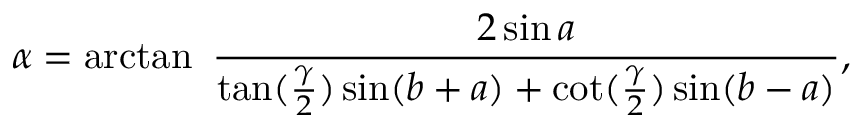<formula> <loc_0><loc_0><loc_500><loc_500>\alpha = \arctan \ { \frac { 2 \sin a } { \tan ( { \frac { \gamma } { 2 } } ) \sin ( b + a ) + \cot ( { \frac { \gamma } { 2 } } ) \sin ( b - a ) } } ,</formula> 